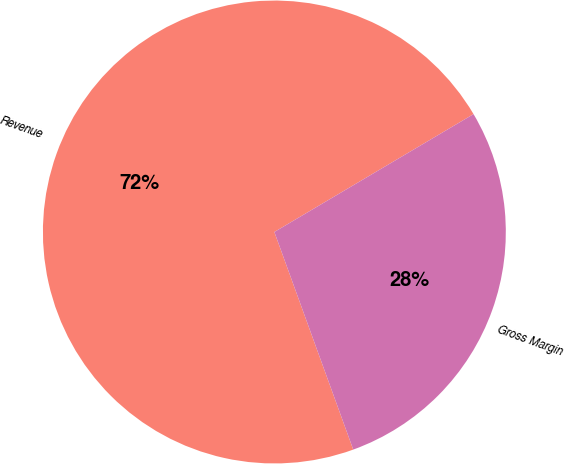<chart> <loc_0><loc_0><loc_500><loc_500><pie_chart><fcel>Revenue<fcel>Gross Margin<nl><fcel>72.03%<fcel>27.97%<nl></chart> 